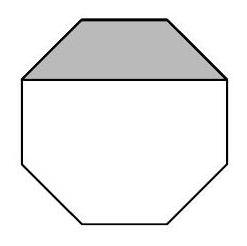Can you explain how the shaded section relates to the whole octagon in terms of dimensions? Certainly! The shaded section in the image could potentially represent one part of the octagon subdivided by drawing lines from vertices to the center. The area of the shaded section might represent one-eighth of the total area if the segments are equal, which is typical in a regular octagon. Each angle in a regular octagon is 135 degrees, and if the shaded section occupies a symmetrical segment, its area gives a clue to calculating the total area by multiplying the shaded area by eight. 